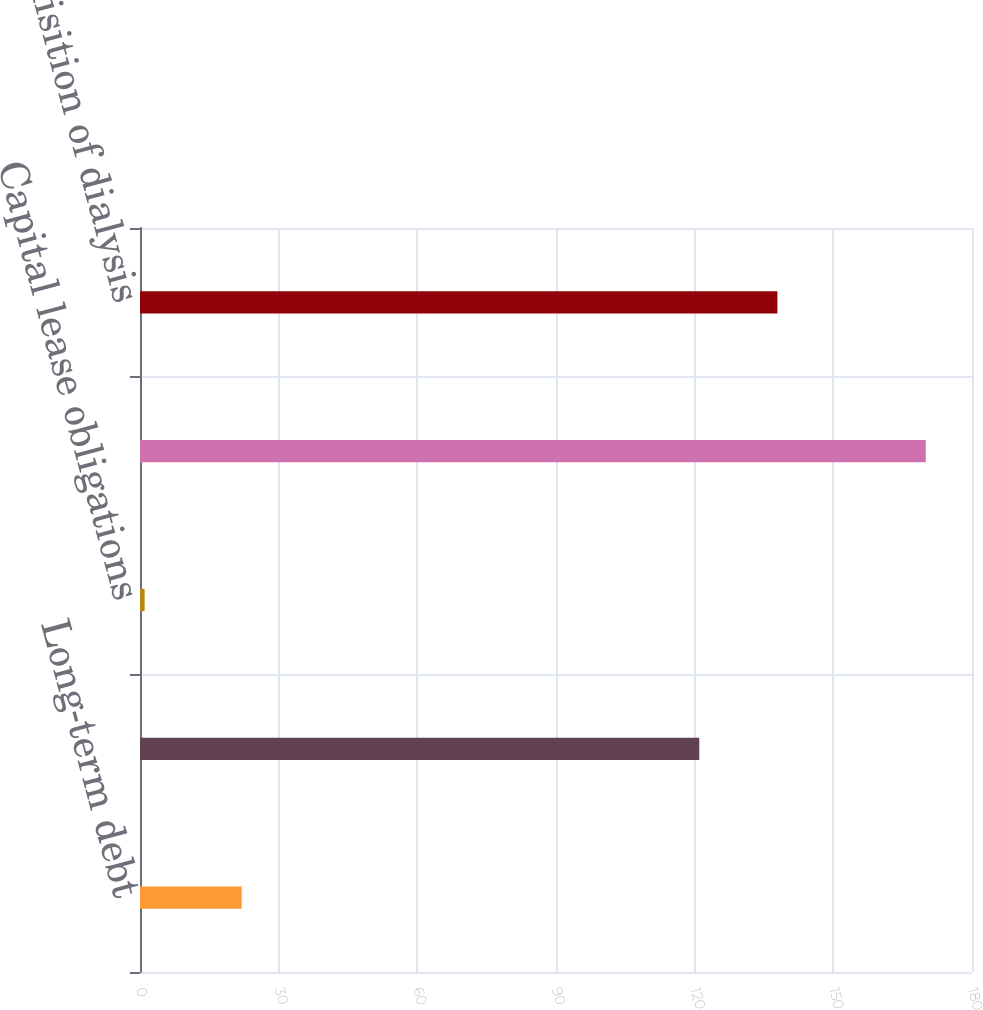Convert chart to OTSL. <chart><loc_0><loc_0><loc_500><loc_500><bar_chart><fcel>Long-term debt<fcel>Interest payments on senior<fcel>Capital lease obligations<fcel>Operating leases<fcel>Acquisition of dialysis<nl><fcel>22<fcel>121<fcel>1<fcel>170<fcel>137.9<nl></chart> 